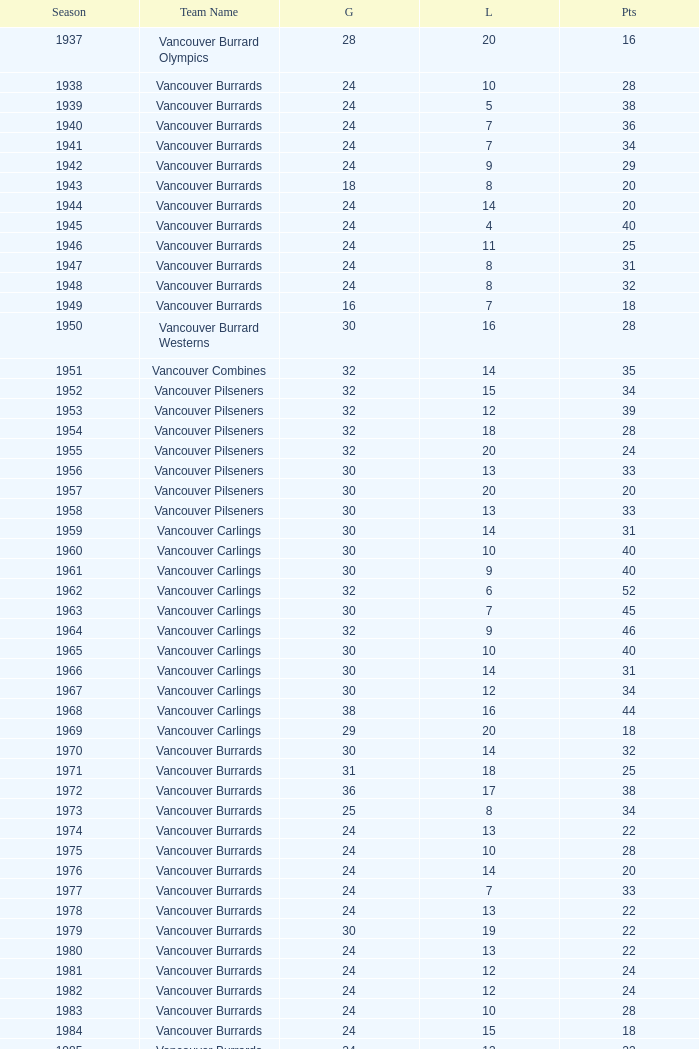What's the sum of points for the 1963 season when there are more than 30 games? None. 